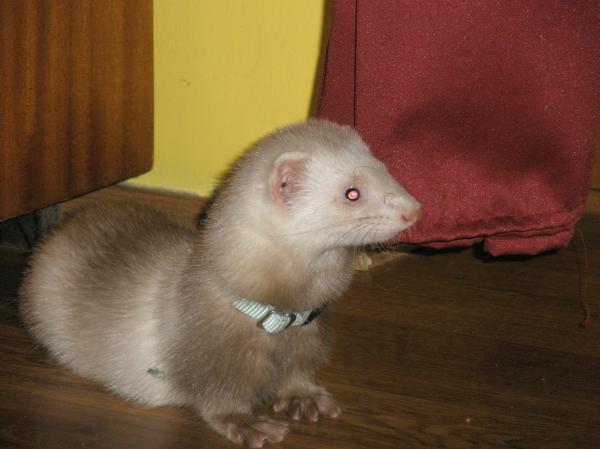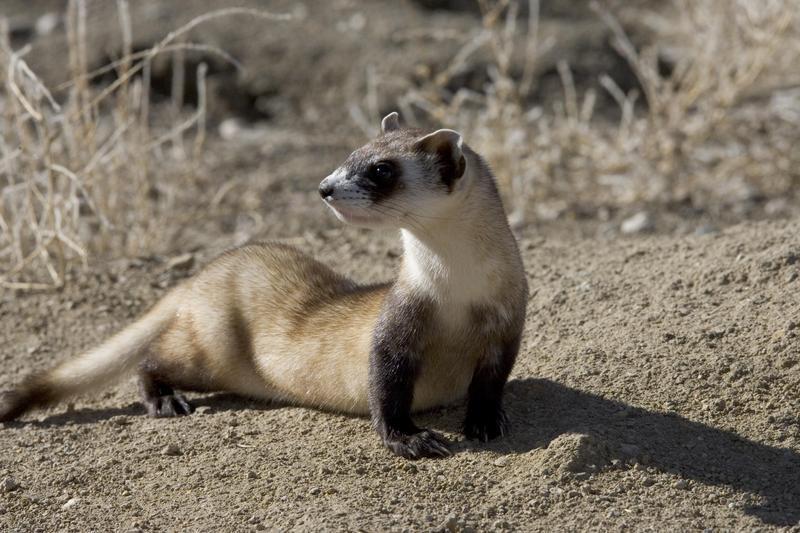The first image is the image on the left, the second image is the image on the right. Analyze the images presented: Is the assertion "There is a ferret in the outdoors looking directly at the camera in the right image." valid? Answer yes or no. No. 